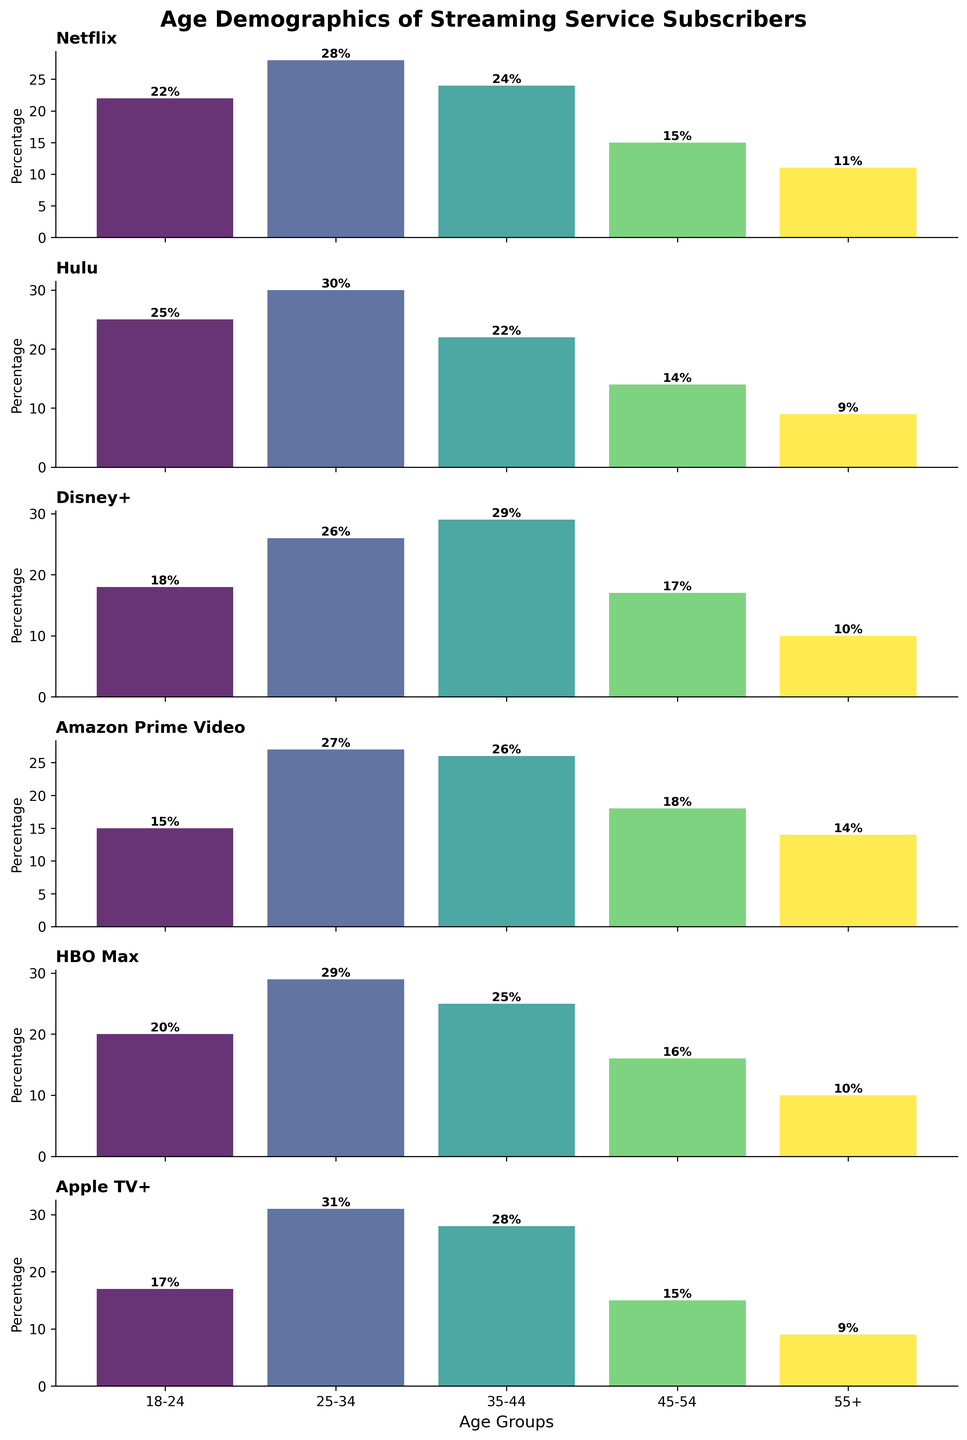what is the title of the figure? The title is above the plots and it reads 'Age Demographics of Streaming Service Subscribers'.
Answer: Age Demographics of Streaming Service Subscribers How many age groups are represented in each subplot? Each subplot has vertical bars representing age groups, and the x-axis lists five age groups.
Answer: 5 Which streaming service has the highest percentage of subscribers in the 18-24 age group? Observing the first bar in each subplot, Hulu has the highest bar for this age group at 25%.
Answer: Hulu What percentage of 25-34 year-olds are Netflix subscribers? The second bar in the Netflix subplot shows the percentage for 25-34 year-olds, which is labeled 28%.
Answer: 28% How does Disney+ compare with Amazon Prime Video in the 35-44 age group? Comparing the third bars in both subplots, Disney+ has a slightly higher percentage (29%) compared to Amazon Prime Video (26%).
Answer: Disney+ has a higher percentage What is the average percentage of subscribers aged 45-54 across all platforms? Sum the 45-54 percentage for each platform (15+14+17+18+16+15) = 95 and divide by the number of platforms (6). The average is 95/6 = 15.83, approximately 16%.
Answer: 16% Which platform has the lowest percentage of subscribers in the 55+ age group? Observing the last bar in each subplot, Hulu has the lowest percentage at 9%.
Answer: Hulu Which platforms have their highest percentage of subscribers in the 25-34 age group? Checking each subplot, Apple TV+ (31%), Hulu (30%), and HBO Max (29%) have the highest bars for the 25-34 age group.
Answer: Apple TV+, Hulu, HBO Max Which age group does Amazon Prime Video have the smallest percentage of subscribers? In the Amazon Prime Video subplot, the first bar (18-24 age group) has the smallest percentage at 15%.
Answer: 18-24 How does the age distribution in Apple TV+ compare to Netflix? Comparing all bars, both platforms have their highest subscription in the 25-34 age group, but Apple TV+ has a higher percentage (31% to Netflix's 28%) and a lower percentage in the 18-24 and 55+ age groups.
Answer: Apple TV+ has a higher percentage in 25-34 and lower in 18-24, 55+ 